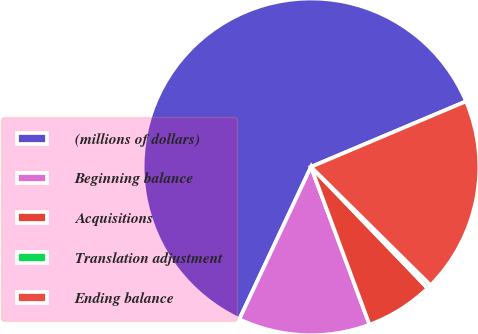<chart> <loc_0><loc_0><loc_500><loc_500><pie_chart><fcel>(millions of dollars)<fcel>Beginning balance<fcel>Acquisitions<fcel>Translation adjustment<fcel>Ending balance<nl><fcel>61.65%<fcel>12.65%<fcel>6.53%<fcel>0.4%<fcel>18.78%<nl></chart> 